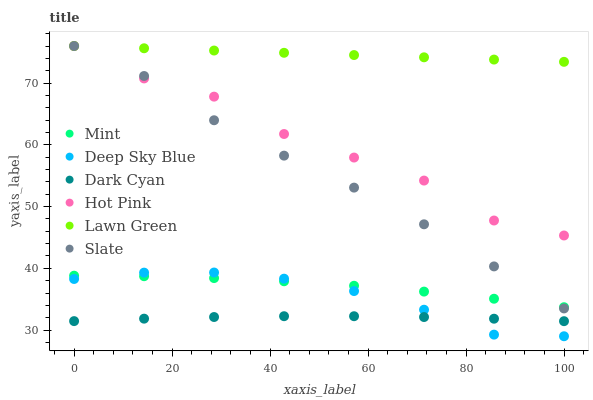Does Dark Cyan have the minimum area under the curve?
Answer yes or no. Yes. Does Lawn Green have the maximum area under the curve?
Answer yes or no. Yes. Does Slate have the minimum area under the curve?
Answer yes or no. No. Does Slate have the maximum area under the curve?
Answer yes or no. No. Is Lawn Green the smoothest?
Answer yes or no. Yes. Is Hot Pink the roughest?
Answer yes or no. Yes. Is Slate the smoothest?
Answer yes or no. No. Is Slate the roughest?
Answer yes or no. No. Does Deep Sky Blue have the lowest value?
Answer yes or no. Yes. Does Slate have the lowest value?
Answer yes or no. No. Does Hot Pink have the highest value?
Answer yes or no. Yes. Does Deep Sky Blue have the highest value?
Answer yes or no. No. Is Dark Cyan less than Lawn Green?
Answer yes or no. Yes. Is Slate greater than Dark Cyan?
Answer yes or no. Yes. Does Lawn Green intersect Hot Pink?
Answer yes or no. Yes. Is Lawn Green less than Hot Pink?
Answer yes or no. No. Is Lawn Green greater than Hot Pink?
Answer yes or no. No. Does Dark Cyan intersect Lawn Green?
Answer yes or no. No. 